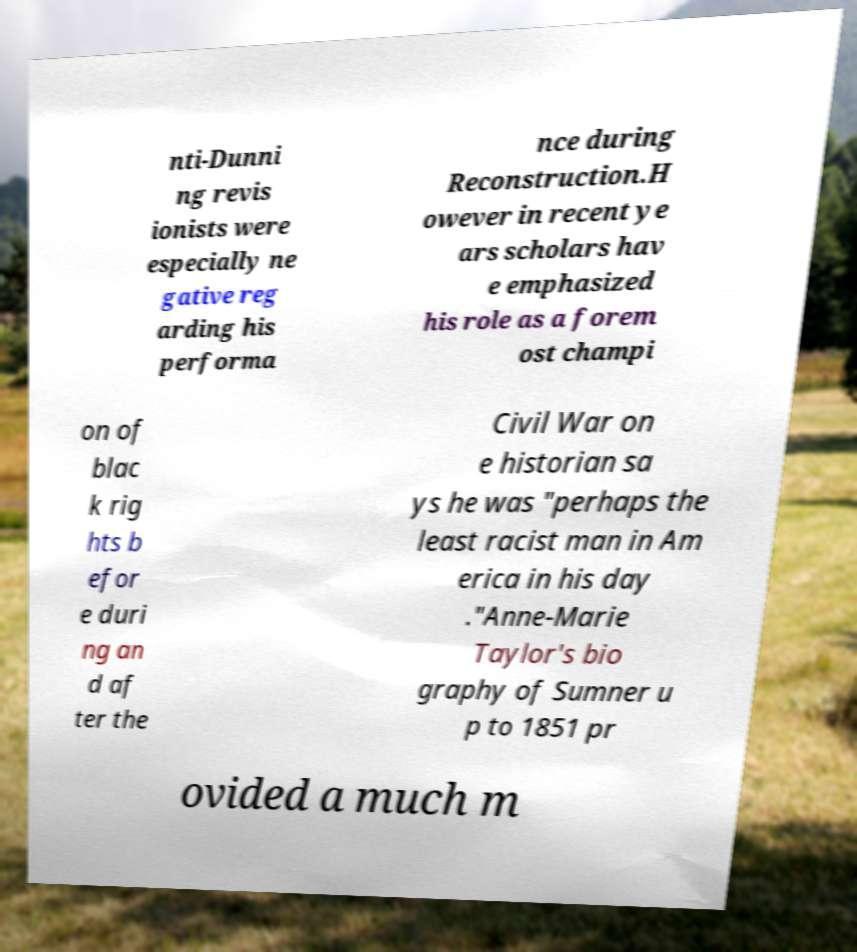Please read and relay the text visible in this image. What does it say? nti-Dunni ng revis ionists were especially ne gative reg arding his performa nce during Reconstruction.H owever in recent ye ars scholars hav e emphasized his role as a forem ost champi on of blac k rig hts b efor e duri ng an d af ter the Civil War on e historian sa ys he was "perhaps the least racist man in Am erica in his day ."Anne-Marie Taylor's bio graphy of Sumner u p to 1851 pr ovided a much m 